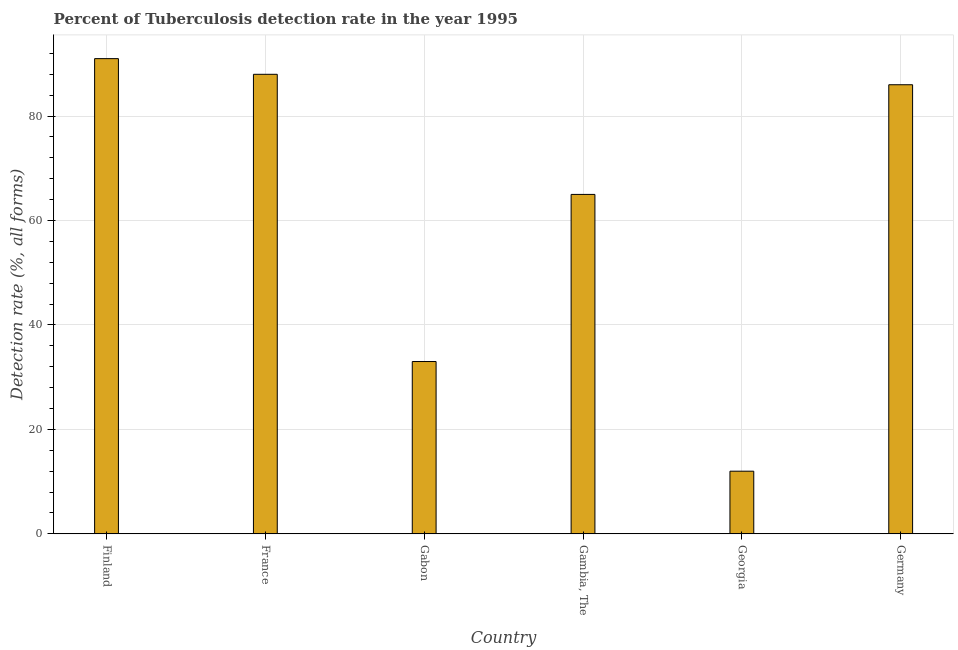Does the graph contain any zero values?
Provide a short and direct response. No. What is the title of the graph?
Ensure brevity in your answer.  Percent of Tuberculosis detection rate in the year 1995. What is the label or title of the X-axis?
Your response must be concise. Country. What is the label or title of the Y-axis?
Your answer should be compact. Detection rate (%, all forms). Across all countries, what is the maximum detection rate of tuberculosis?
Offer a terse response. 91. In which country was the detection rate of tuberculosis minimum?
Ensure brevity in your answer.  Georgia. What is the sum of the detection rate of tuberculosis?
Your answer should be compact. 375. What is the average detection rate of tuberculosis per country?
Give a very brief answer. 62.5. What is the median detection rate of tuberculosis?
Give a very brief answer. 75.5. In how many countries, is the detection rate of tuberculosis greater than 48 %?
Give a very brief answer. 4. What is the ratio of the detection rate of tuberculosis in Finland to that in Georgia?
Offer a terse response. 7.58. What is the difference between the highest and the second highest detection rate of tuberculosis?
Your answer should be very brief. 3. What is the difference between the highest and the lowest detection rate of tuberculosis?
Your response must be concise. 79. How many bars are there?
Offer a very short reply. 6. What is the difference between two consecutive major ticks on the Y-axis?
Make the answer very short. 20. Are the values on the major ticks of Y-axis written in scientific E-notation?
Make the answer very short. No. What is the Detection rate (%, all forms) in Finland?
Keep it short and to the point. 91. What is the Detection rate (%, all forms) in Gabon?
Give a very brief answer. 33. What is the Detection rate (%, all forms) in Gambia, The?
Offer a terse response. 65. What is the Detection rate (%, all forms) in Georgia?
Offer a very short reply. 12. What is the Detection rate (%, all forms) of Germany?
Provide a succinct answer. 86. What is the difference between the Detection rate (%, all forms) in Finland and France?
Provide a succinct answer. 3. What is the difference between the Detection rate (%, all forms) in Finland and Georgia?
Keep it short and to the point. 79. What is the difference between the Detection rate (%, all forms) in Finland and Germany?
Your answer should be very brief. 5. What is the difference between the Detection rate (%, all forms) in France and Gambia, The?
Your response must be concise. 23. What is the difference between the Detection rate (%, all forms) in France and Germany?
Give a very brief answer. 2. What is the difference between the Detection rate (%, all forms) in Gabon and Gambia, The?
Your answer should be compact. -32. What is the difference between the Detection rate (%, all forms) in Gabon and Germany?
Make the answer very short. -53. What is the difference between the Detection rate (%, all forms) in Georgia and Germany?
Make the answer very short. -74. What is the ratio of the Detection rate (%, all forms) in Finland to that in France?
Your answer should be very brief. 1.03. What is the ratio of the Detection rate (%, all forms) in Finland to that in Gabon?
Give a very brief answer. 2.76. What is the ratio of the Detection rate (%, all forms) in Finland to that in Georgia?
Give a very brief answer. 7.58. What is the ratio of the Detection rate (%, all forms) in Finland to that in Germany?
Keep it short and to the point. 1.06. What is the ratio of the Detection rate (%, all forms) in France to that in Gabon?
Make the answer very short. 2.67. What is the ratio of the Detection rate (%, all forms) in France to that in Gambia, The?
Provide a succinct answer. 1.35. What is the ratio of the Detection rate (%, all forms) in France to that in Georgia?
Offer a terse response. 7.33. What is the ratio of the Detection rate (%, all forms) in Gabon to that in Gambia, The?
Keep it short and to the point. 0.51. What is the ratio of the Detection rate (%, all forms) in Gabon to that in Georgia?
Provide a succinct answer. 2.75. What is the ratio of the Detection rate (%, all forms) in Gabon to that in Germany?
Your response must be concise. 0.38. What is the ratio of the Detection rate (%, all forms) in Gambia, The to that in Georgia?
Give a very brief answer. 5.42. What is the ratio of the Detection rate (%, all forms) in Gambia, The to that in Germany?
Your answer should be compact. 0.76. What is the ratio of the Detection rate (%, all forms) in Georgia to that in Germany?
Provide a short and direct response. 0.14. 